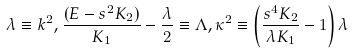Convert formula to latex. <formula><loc_0><loc_0><loc_500><loc_500>\lambda \equiv k ^ { 2 } , \frac { ( E - s ^ { 2 } K _ { 2 } ) } { K _ { 1 } } - \frac { \lambda } { 2 } \equiv \Lambda , \kappa ^ { 2 } \equiv \left ( \frac { s ^ { 4 } K _ { 2 } } { \lambda K _ { 1 } } - 1 \right ) \lambda</formula> 